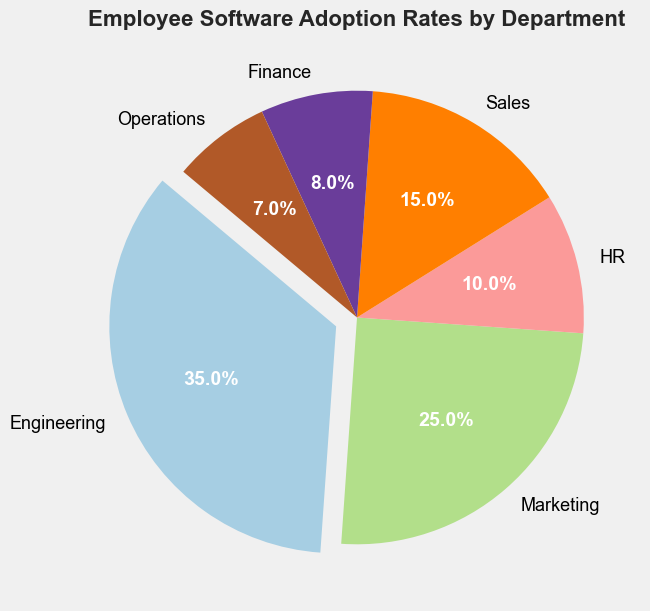What's the department with the highest software adoption rate? By looking at the pie chart, the largest wedge is the one for Engineering, which also stands out due to the explode effect used. This indicates that the Engineering department has the highest adoption rate.
Answer: Engineering Which department has the lowest adoption rate? The smallest wedge in the pie chart represents the Operations department, indicating it has the lowest software adoption rate.
Answer: Operations What is the total adoption rate for Marketing and Sales departments combined? The adoption rate for Marketing is 25% and for Sales is 15%. Adding these together gives 25% + 15% = 40%.
Answer: 40% Compare the adoption rates of HR and Finance departments. Which one is higher? The pie chart shows that the HR department has an adoption rate of 10%, while the Finance department has 8%. Since 10% is greater than 8%, HR has a higher adoption rate than Finance.
Answer: HR How many departments have an adoption rate greater than 10%? By examining the pie chart, we see that Engineering (35%), Marketing (25%), and Sales (15%) all have adoption rates greater than 10%. Therefore, there are 3 departments with adoption rates greater than 10%.
Answer: 3 Which department's adoption rate is closest to 30%? The pie chart indicates that the Marketing department has an adoption rate of 25%, which is the closest to 30% among all departments.
Answer: Marketing If the adoption rates of Engineering and Marketing are combined, what fraction of the total adoption rate do they represent? The adoption rate for Engineering is 35% and for Marketing is 25%. Summing these gives 35% + 25% = 60%. Therefore, the fraction of the total adoption rate they represent is 60/100 = 3/5.
Answer: 3/5 What is the difference in adoption rates between the Sales and Operations departments? The adoption rate for Sales is 15% and for Operations is 7%. The difference is 15% - 7% = 8%.
Answer: 8% Which department has a software adoption rate closest to the median adoption rate across all departments shown? The adoption rates are: 35%, 25%, 15%, 10%, 8%, and 7%. Arranging them in ascending order: 7%, 8%, 10%, 15%, 25%, 35%. The median of these values is the average of the 3rd and 4th values: (10% + 15%)/2 = 12.5%. The department with the adoption rate closest to this is HR with 10%.
Answer: HR Identify the two departments with the smallest adoption rates and provide their combined total. The pie chart indicates that Finance (8%) and Operations (7%) have the smallest adoption rates. Their combined total is 8% + 7% = 15%.
Answer: 15% 